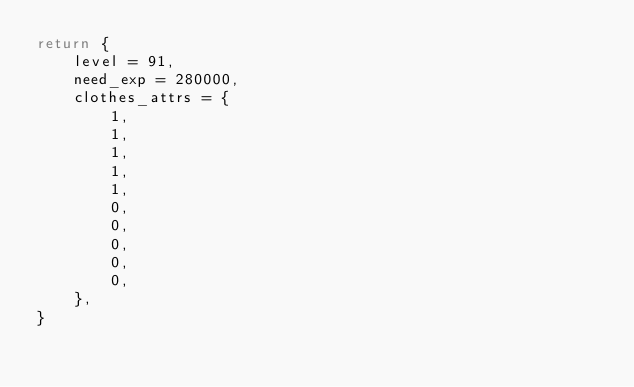Convert code to text. <code><loc_0><loc_0><loc_500><loc_500><_Lua_>return {
    level = 91,
    need_exp = 280000,
    clothes_attrs = {
        1,
        1,
        1,
        1,
        1,
        0,
        0,
        0,
        0,
        0,
    },
}</code> 